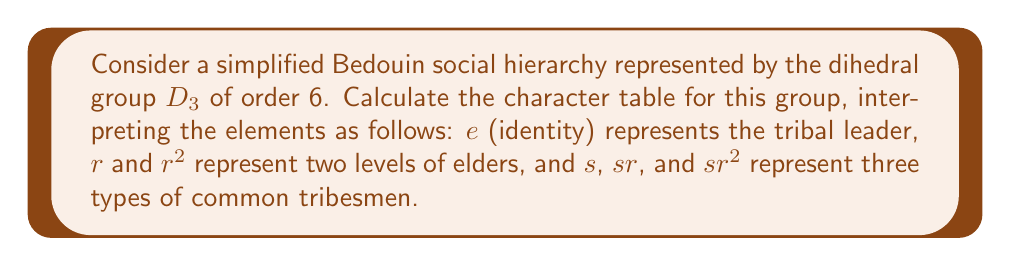Provide a solution to this math problem. To calculate the character table for the dihedral group $D_3$, we follow these steps:

1) First, identify the conjugacy classes of $D_3$:
   - $\{e\}$: the tribal leader
   - $\{r, r^2\}$: the elders
   - $\{s, sr, sr^2\}$: the common tribesmen

2) The number of irreducible representations equals the number of conjugacy classes, which is 3.

3) We know that $D_3$ has two 1-dimensional representations and one 2-dimensional representation:
   - The trivial representation $\chi_1$
   - The sign representation $\chi_2$
   - The 2-dimensional representation $\chi_3$

4) For $\chi_1$, all characters are 1.

5) For $\chi_2$:
   $\chi_2(e) = 1$
   $\chi_2(r) = \chi_2(r^2) = 1$
   $\chi_2(s) = \chi_2(sr) = \chi_2(sr^2) = -1$

6) For $\chi_3$, we can use the formula for the character of a rotation by angle $\theta$:
   $\chi_3(r) = \chi_3(r^2) = 2\cos(2\pi/3) = -1$
   
   And for reflections:
   $\chi_3(s) = \chi_3(sr) = \chi_3(sr^2) = 0$

7) Construct the character table:

   $$
   \begin{array}{c|ccc}
    D_3 & \{e\} & \{r, r^2\} & \{s, sr, sr^2\} \\
    \hline
    \chi_1 & 1 & 1 & 1 \\
    \chi_2 & 1 & 1 & -1 \\
    \chi_3 & 2 & -1 & 0
   \end{array}
   $$

This character table represents how different "classes" of the Bedouin society (leader, elders, common tribesmen) are viewed in different abstract "perspectives" (the irreducible representations).
Answer: $$
\begin{array}{c|ccc}
D_3 & \{e\} & \{r, r^2\} & \{s, sr, sr^2\} \\
\hline
\chi_1 & 1 & 1 & 1 \\
\chi_2 & 1 & 1 & -1 \\
\chi_3 & 2 & -1 & 0
\end{array}
$$ 